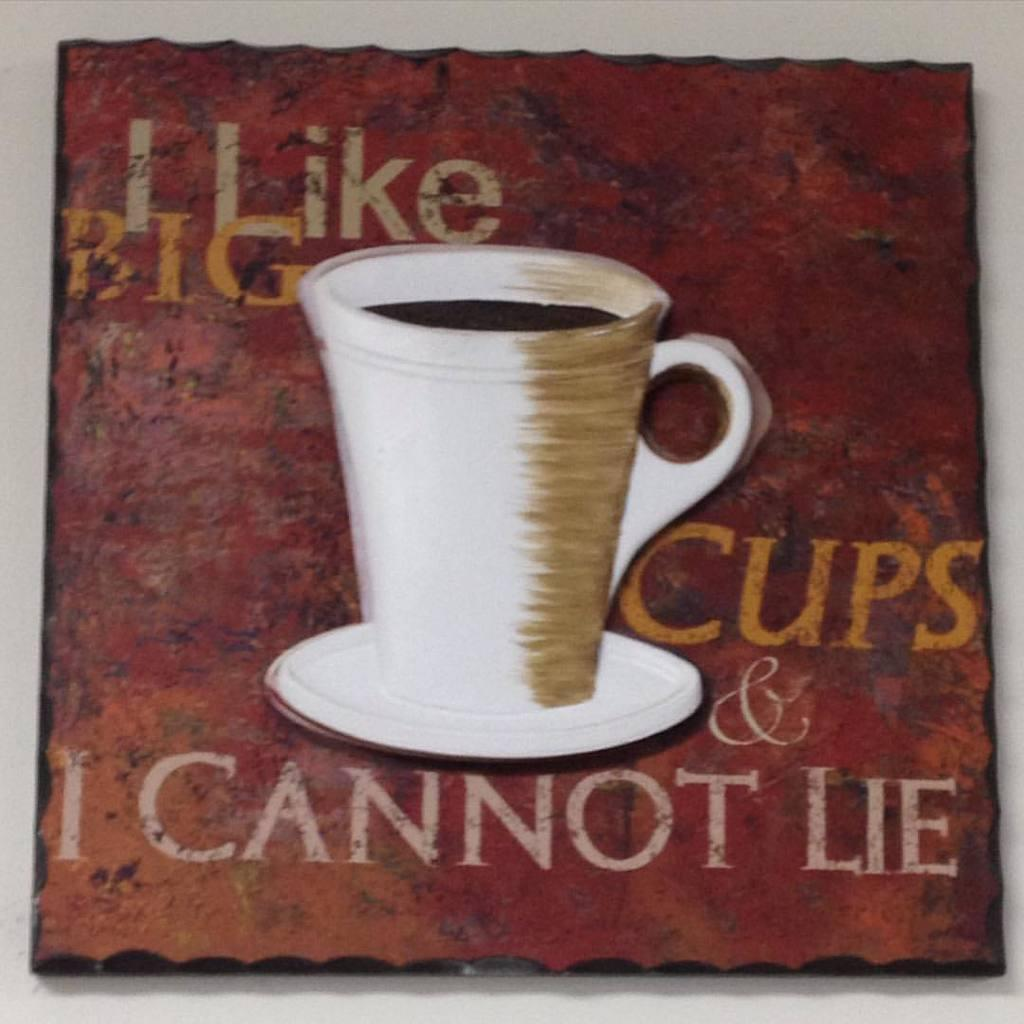<image>
Write a terse but informative summary of the picture. A wall decoration has a picture of coffee and the phrases I Like, Big, Cups, and I cannot lie printed on it. 